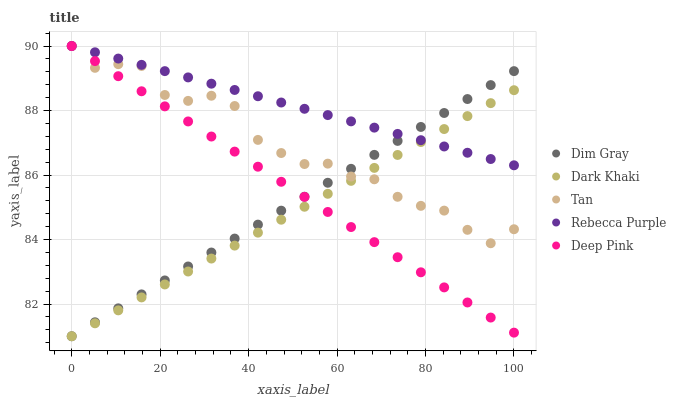Does Dark Khaki have the minimum area under the curve?
Answer yes or no. Yes. Does Rebecca Purple have the maximum area under the curve?
Answer yes or no. Yes. Does Tan have the minimum area under the curve?
Answer yes or no. No. Does Tan have the maximum area under the curve?
Answer yes or no. No. Is Deep Pink the smoothest?
Answer yes or no. Yes. Is Tan the roughest?
Answer yes or no. Yes. Is Dim Gray the smoothest?
Answer yes or no. No. Is Dim Gray the roughest?
Answer yes or no. No. Does Dark Khaki have the lowest value?
Answer yes or no. Yes. Does Tan have the lowest value?
Answer yes or no. No. Does Deep Pink have the highest value?
Answer yes or no. Yes. Does Dim Gray have the highest value?
Answer yes or no. No. Does Dark Khaki intersect Dim Gray?
Answer yes or no. Yes. Is Dark Khaki less than Dim Gray?
Answer yes or no. No. Is Dark Khaki greater than Dim Gray?
Answer yes or no. No. 